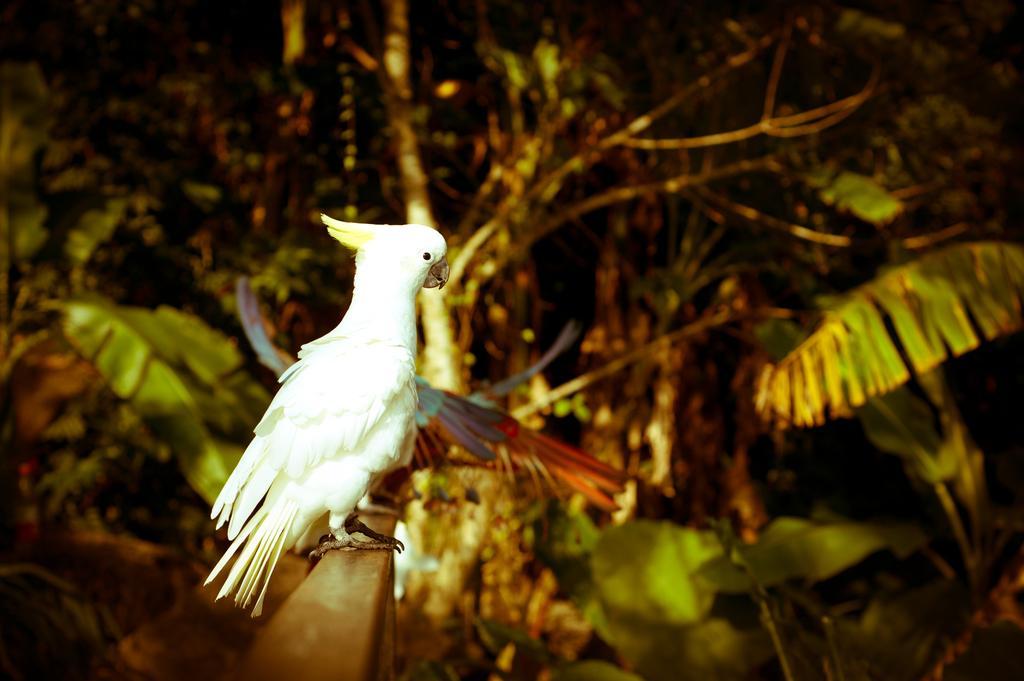How would you summarize this image in a sentence or two? On the left side it is a parrot which is in white color and there are green color trees. 